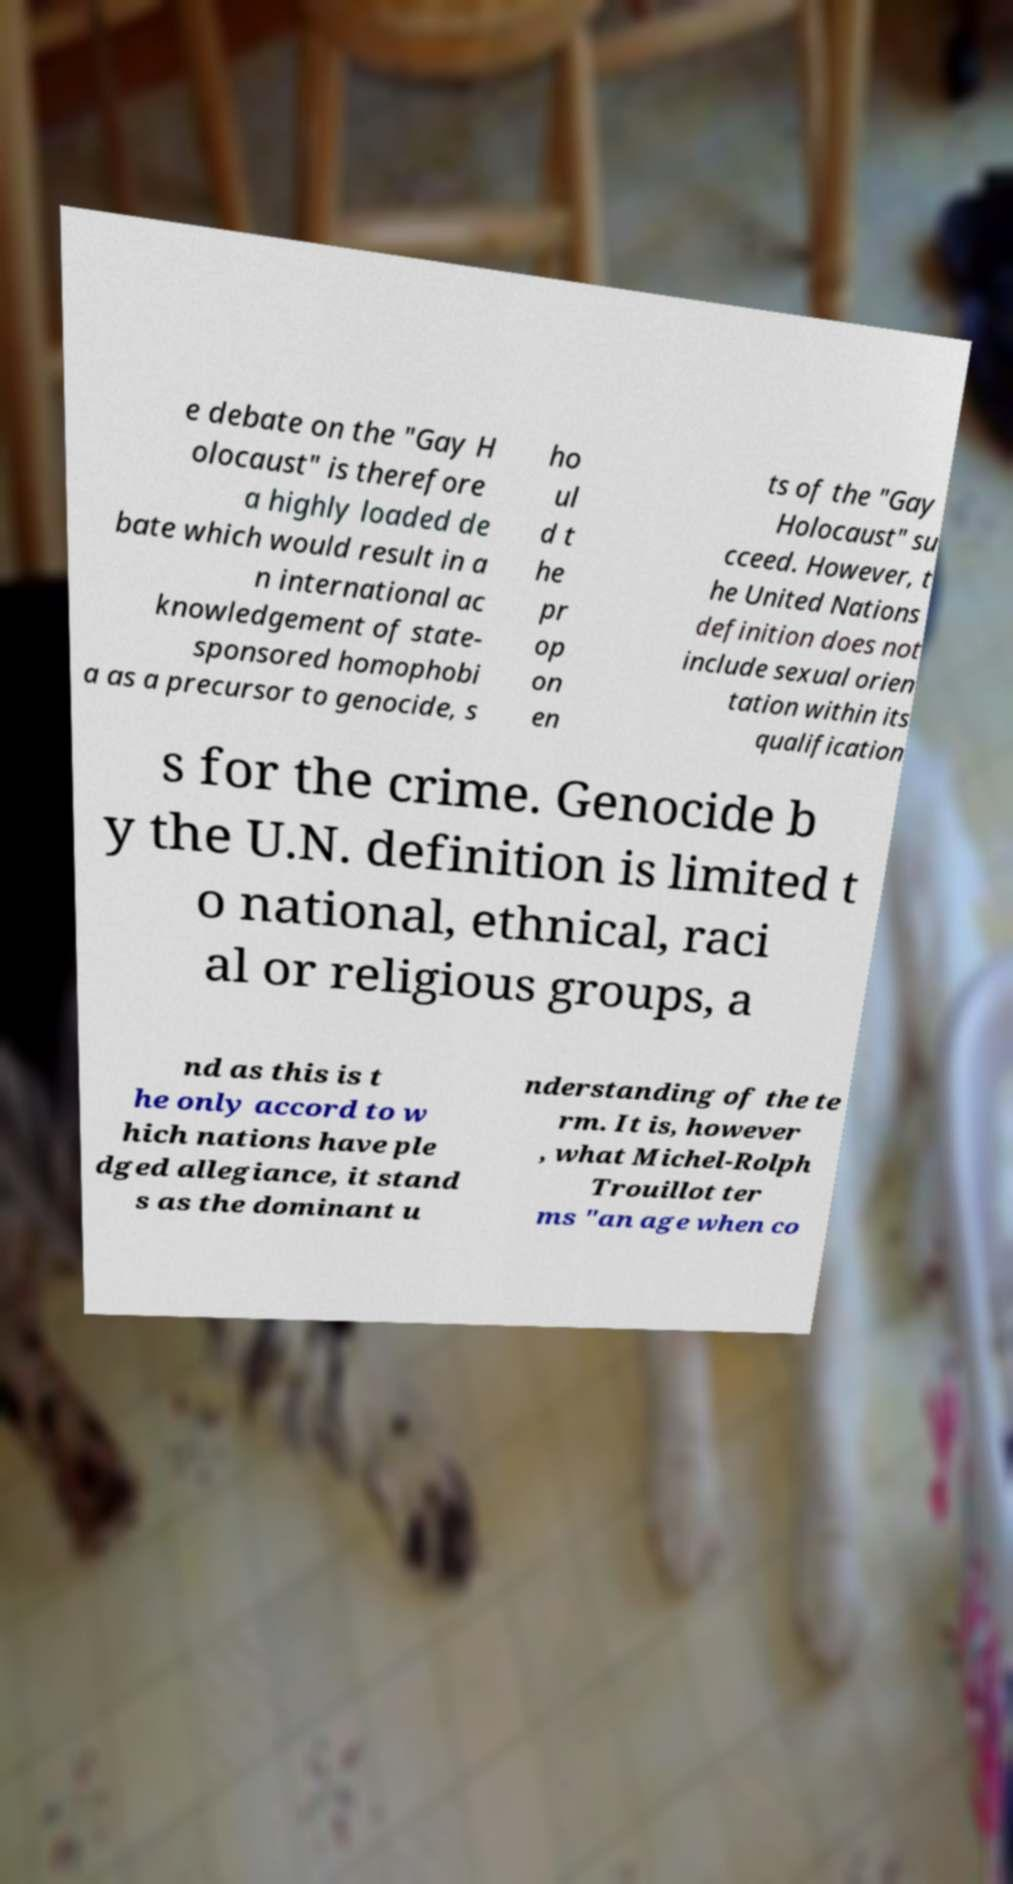Please identify and transcribe the text found in this image. e debate on the "Gay H olocaust" is therefore a highly loaded de bate which would result in a n international ac knowledgement of state- sponsored homophobi a as a precursor to genocide, s ho ul d t he pr op on en ts of the "Gay Holocaust" su cceed. However, t he United Nations definition does not include sexual orien tation within its qualification s for the crime. Genocide b y the U.N. definition is limited t o national, ethnical, raci al or religious groups, a nd as this is t he only accord to w hich nations have ple dged allegiance, it stand s as the dominant u nderstanding of the te rm. It is, however , what Michel-Rolph Trouillot ter ms "an age when co 